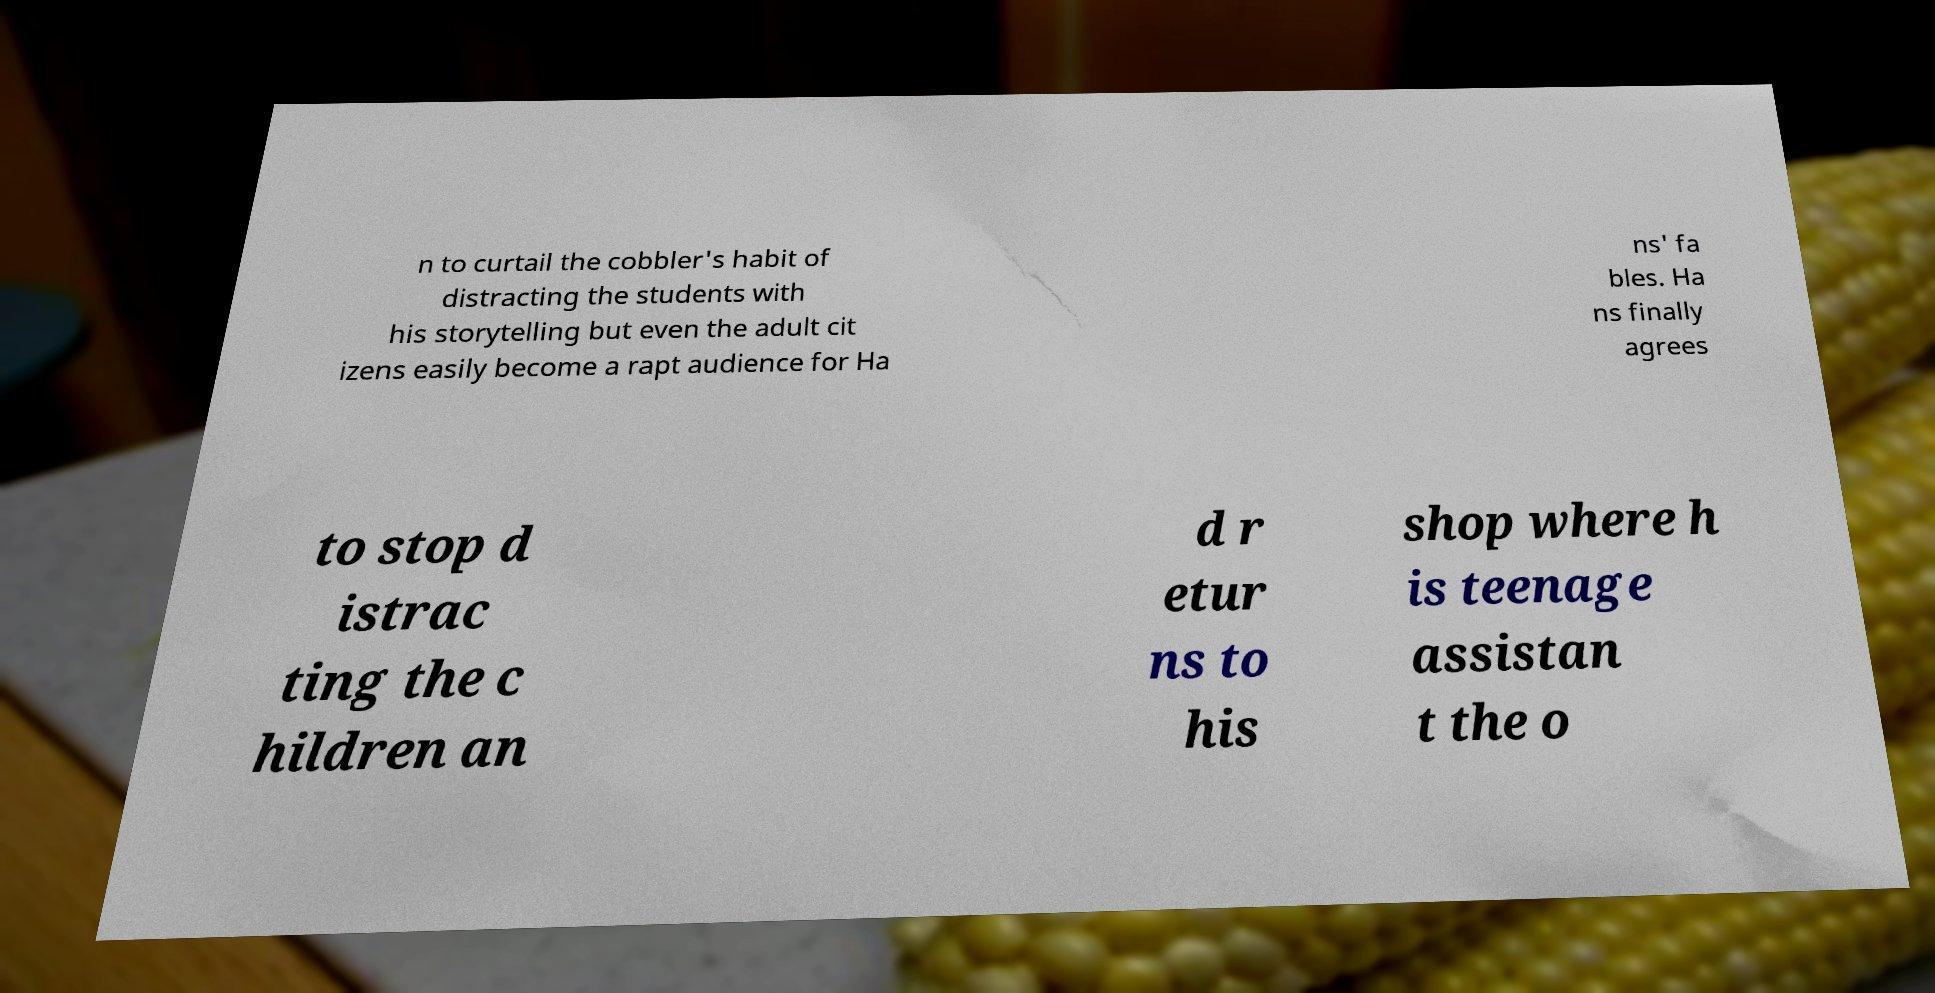Can you read and provide the text displayed in the image?This photo seems to have some interesting text. Can you extract and type it out for me? n to curtail the cobbler's habit of distracting the students with his storytelling but even the adult cit izens easily become a rapt audience for Ha ns' fa bles. Ha ns finally agrees to stop d istrac ting the c hildren an d r etur ns to his shop where h is teenage assistan t the o 